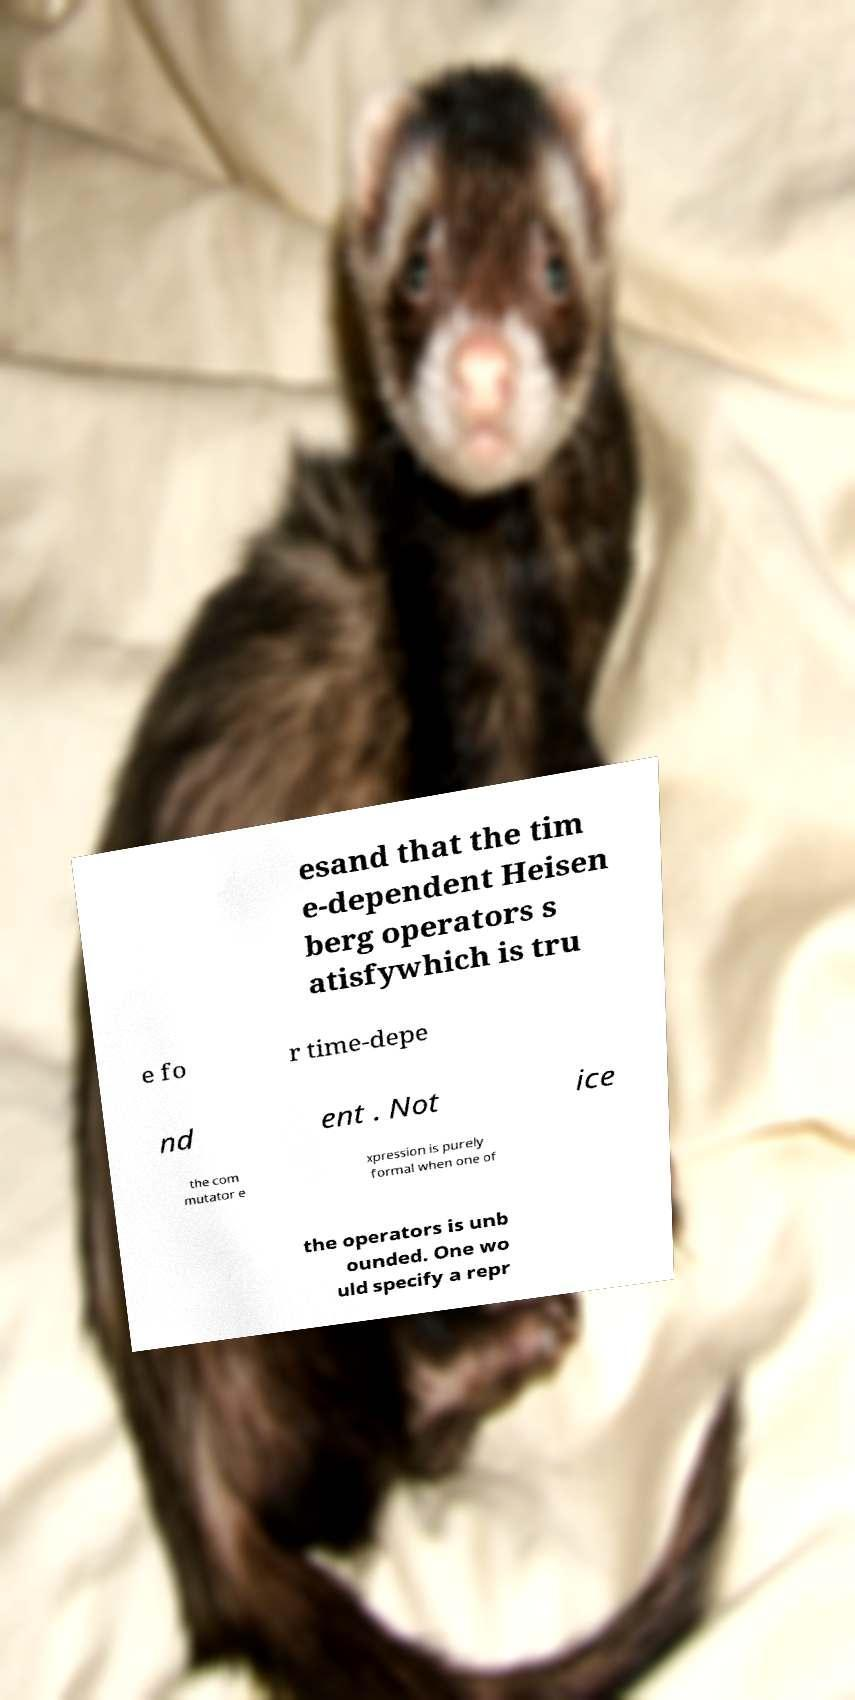There's text embedded in this image that I need extracted. Can you transcribe it verbatim? esand that the tim e-dependent Heisen berg operators s atisfywhich is tru e fo r time-depe nd ent . Not ice the com mutator e xpression is purely formal when one of the operators is unb ounded. One wo uld specify a repr 